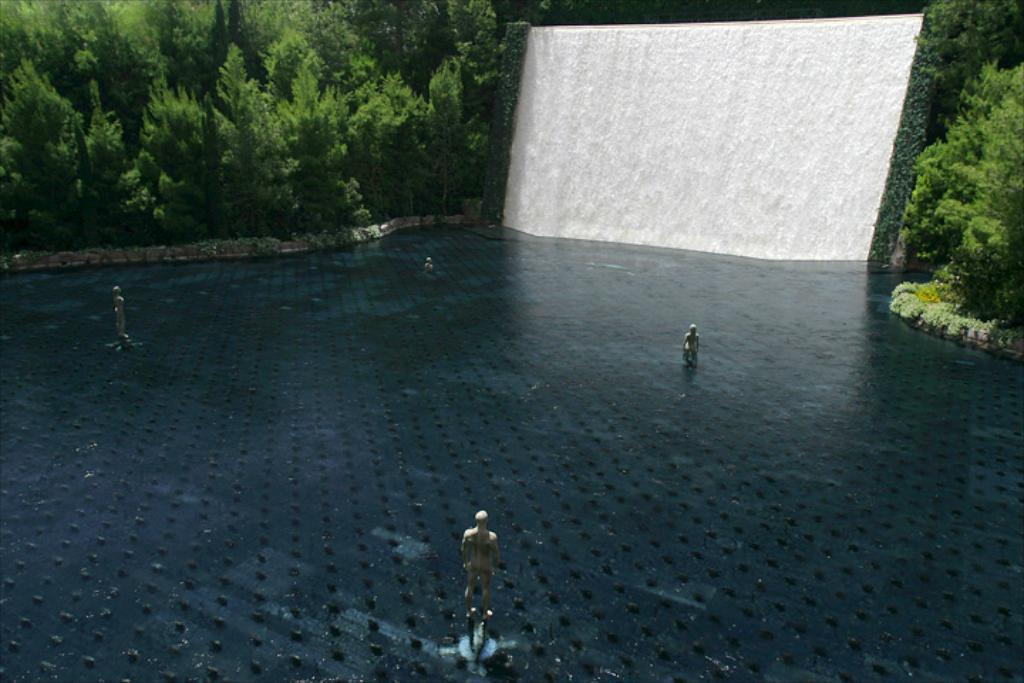How would you summarize this image in a sentence or two? In the center of the image we can see a few statues in the water. In the background, we can see trees and a waterfall. 